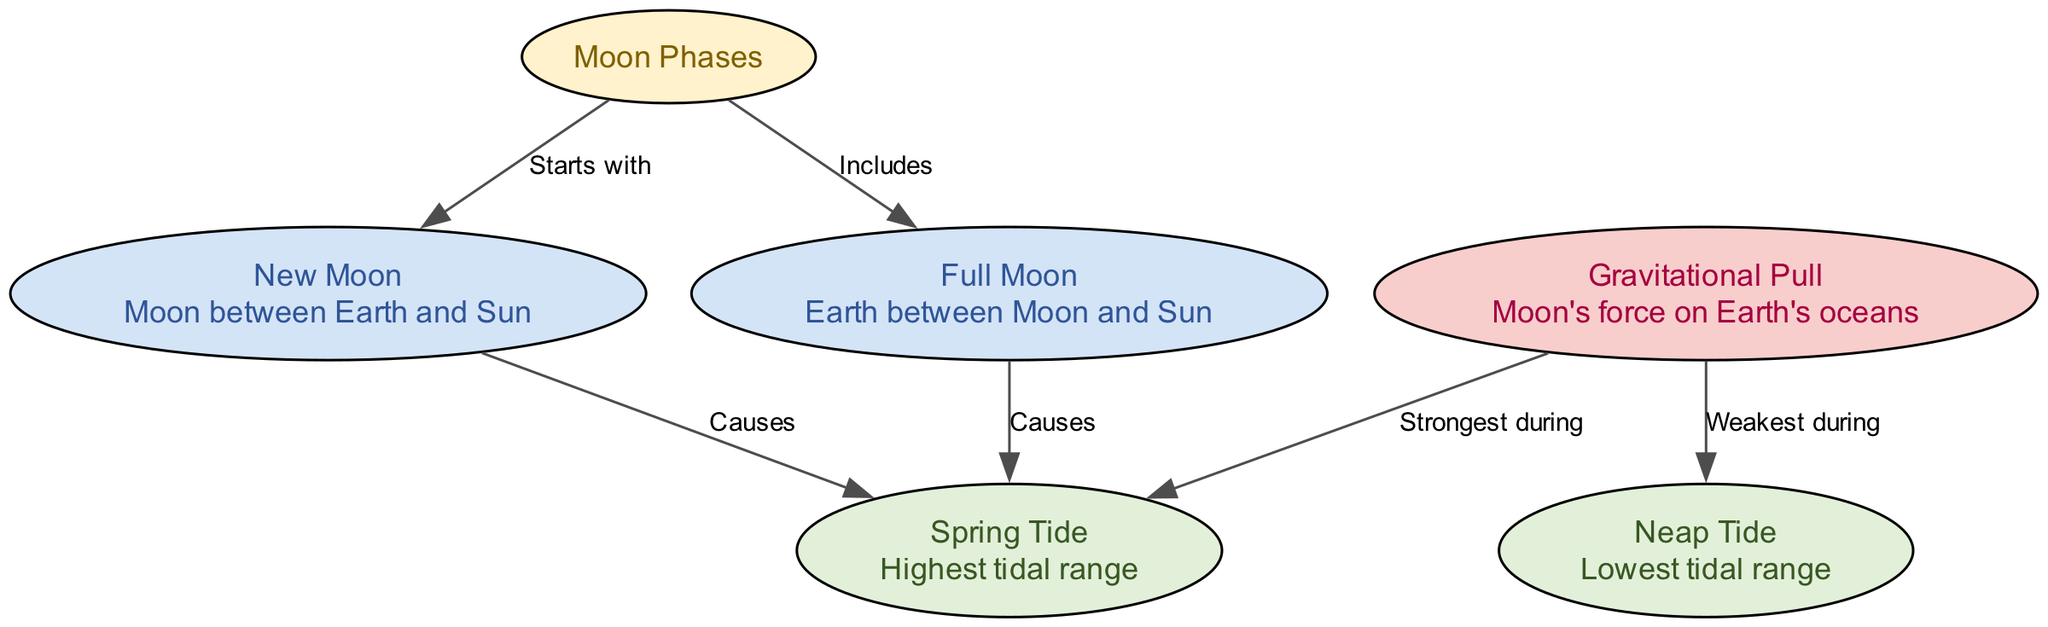¿Cuántas fases principales de la luna hay? Según el diagrama, se muestra que hay 8 fases principales en el ciclo lunar.
Answer: 8 ¿Qué fase de la luna causa las mareas de primavera? El diagrama indica que tanto la luna nueva como la luna llena causan mareas de primavera.
Answer: Luna nueva y luna llena ¿Cuál es el rango de marea más alto? El diagrama identifica la 'marejada' como el rango de marea más alto.
Answer: Marejada ¿Qué fase de la luna está entre la Tierra y el Sol? Según el diagrama, la luna nueva es la fase que está entre la Tierra y el Sol.
Answer: Luna nueva ¿Cuál es el efecto de la fuerza gravitacional de la luna durante las mareas? El diagrama aclara que la fuerza gravitacional de la luna es más fuerte durante las mareas de primavera y más débil durante las mareas muertas.
Answer: Mareas de primavera y mareas muertas ¿Cómo se relacionan las mareas muertas con la luna nueva y la luna llena? El diagrama muestra que las mareas muertas se producen cuando la fuerza gravitacional de la luna es más débil en comparación con las mareas de primavera. Esto ocurre durante ambas fases opuestas de la luna.
Answer: Fuerza gravitacional débil ¿Qué fase de la luna se incluye en el ciclo lunar? El diagrama menciona que la luna llena es parte de las fases del ciclo lunar.
Answer: Luna llena 